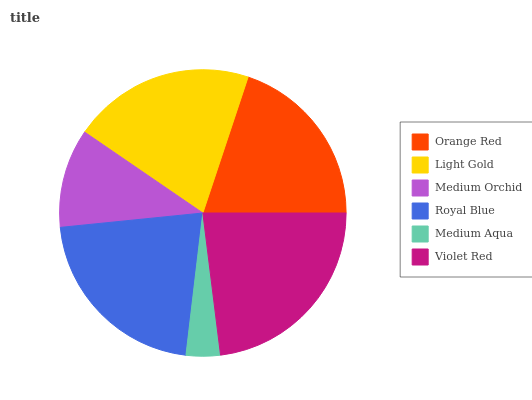Is Medium Aqua the minimum?
Answer yes or no. Yes. Is Violet Red the maximum?
Answer yes or no. Yes. Is Light Gold the minimum?
Answer yes or no. No. Is Light Gold the maximum?
Answer yes or no. No. Is Light Gold greater than Orange Red?
Answer yes or no. Yes. Is Orange Red less than Light Gold?
Answer yes or no. Yes. Is Orange Red greater than Light Gold?
Answer yes or no. No. Is Light Gold less than Orange Red?
Answer yes or no. No. Is Light Gold the high median?
Answer yes or no. Yes. Is Orange Red the low median?
Answer yes or no. Yes. Is Royal Blue the high median?
Answer yes or no. No. Is Medium Aqua the low median?
Answer yes or no. No. 